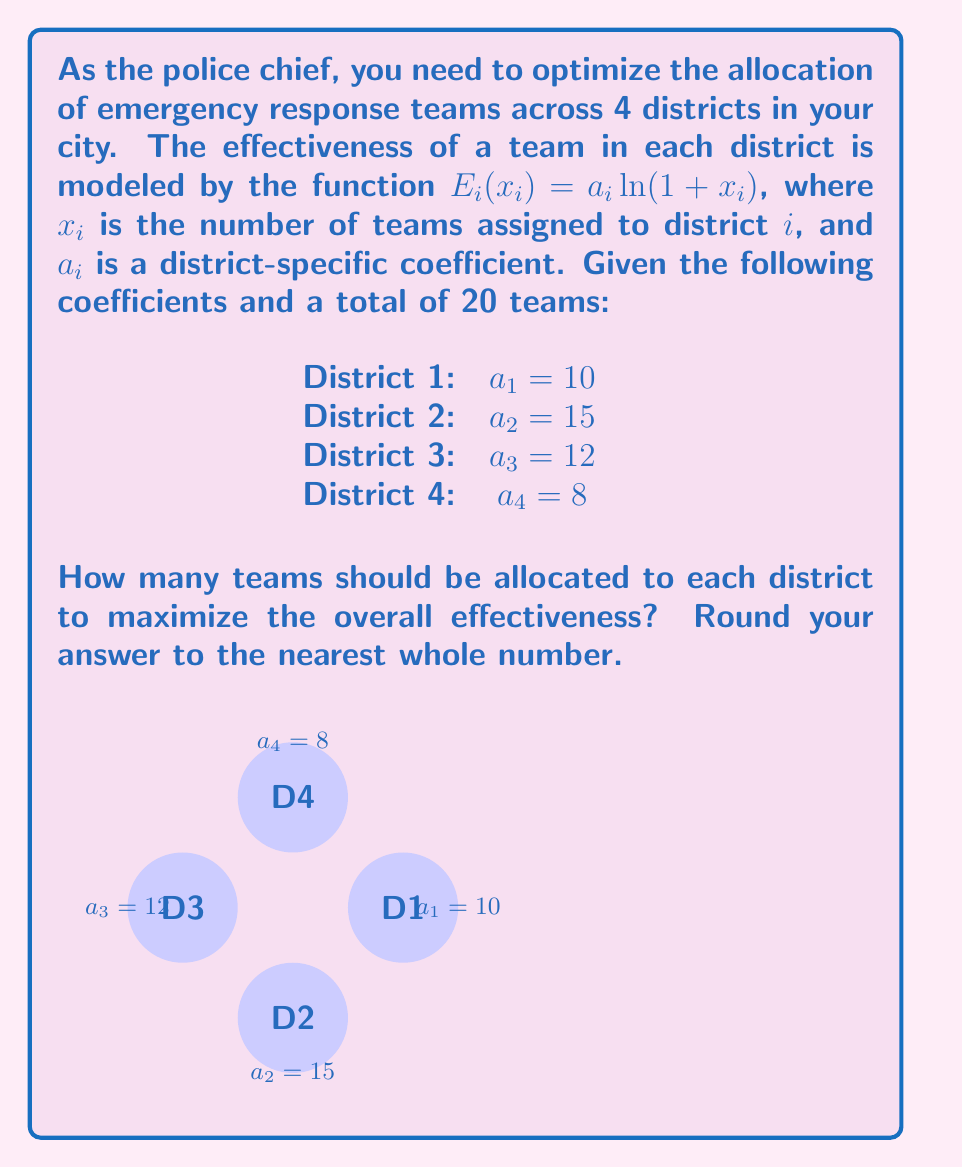Provide a solution to this math problem. To solve this optimization problem, we'll use the method of Lagrange multipliers:

1) The objective function to maximize is:
   $$E = \sum_{i=1}^4 E_i(x_i) = \sum_{i=1}^4 a_i\ln(1+x_i)$$

2) The constraint is:
   $$\sum_{i=1}^4 x_i = 20$$

3) Form the Lagrangian:
   $$L = \sum_{i=1}^4 a_i\ln(1+x_i) - \lambda(\sum_{i=1}^4 x_i - 20)$$

4) Take partial derivatives and set them to zero:
   $$\frac{\partial L}{\partial x_i} = \frac{a_i}{1+x_i} - \lambda = 0$$
   $$\frac{\partial L}{\partial \lambda} = \sum_{i=1}^4 x_i - 20 = 0$$

5) From the first equation:
   $$x_i = \frac{a_i}{\lambda} - 1$$

6) Substitute into the constraint:
   $$\sum_{i=1}^4 (\frac{a_i}{\lambda} - 1) = 20$$
   $$\frac{1}{\lambda}\sum_{i=1}^4 a_i - 4 = 20$$
   $$\frac{1}{\lambda}(10+15+12+8) - 4 = 20$$
   $$\frac{45}{\lambda} = 24$$
   $$\lambda = \frac{45}{24} = 1.875$$

7) Now we can find $x_i$:
   $$x_1 = \frac{10}{1.875} - 1 \approx 4.33$$
   $$x_2 = \frac{15}{1.875} - 1 \approx 7$$
   $$x_3 = \frac{12}{1.875} - 1 \approx 5.4$$
   $$x_4 = \frac{8}{1.875} - 1 \approx 3.27$$

8) Rounding to the nearest whole number:
   $x_1 = 4$, $x_2 = 7$, $x_3 = 5$, $x_4 = 3$

Note: The sum of rounded values is 19, so we add 1 to the district with the highest fractional part (District 3).
Answer: District 1: 4, District 2: 7, District 3: 6, District 4: 3 